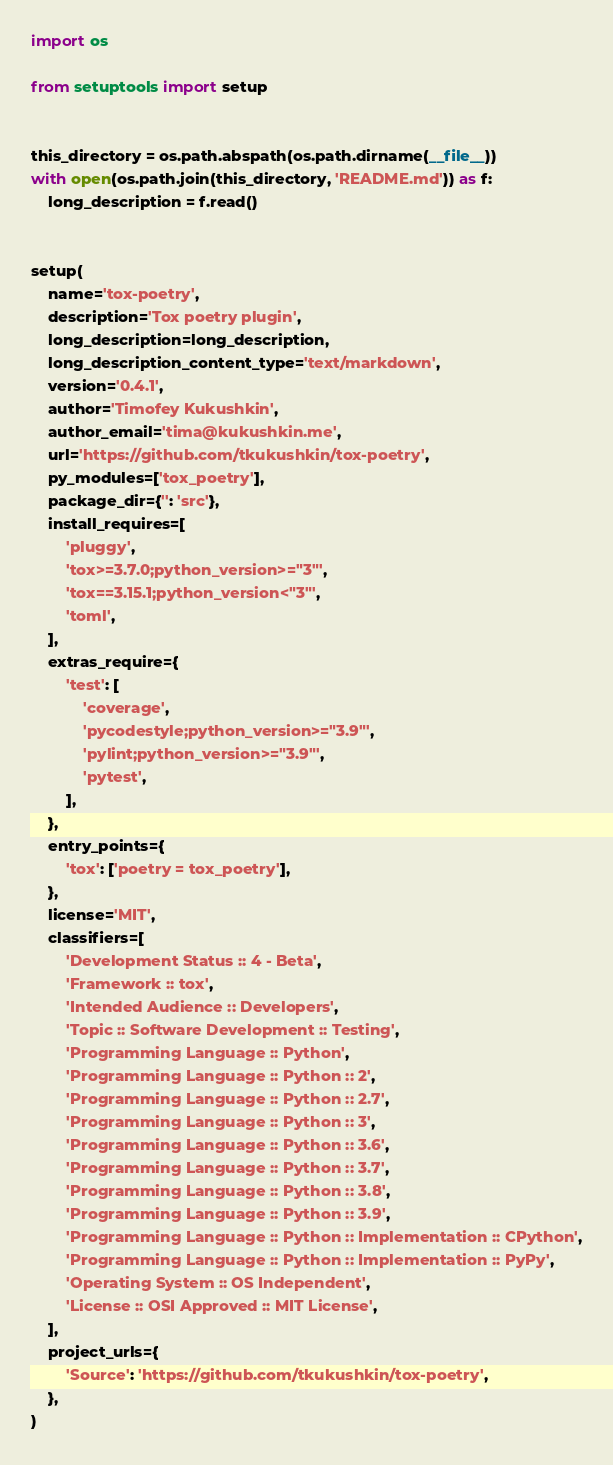<code> <loc_0><loc_0><loc_500><loc_500><_Python_>import os

from setuptools import setup


this_directory = os.path.abspath(os.path.dirname(__file__))
with open(os.path.join(this_directory, 'README.md')) as f:
    long_description = f.read()


setup(
    name='tox-poetry',
    description='Tox poetry plugin',
    long_description=long_description,
    long_description_content_type='text/markdown',
    version='0.4.1',
    author='Timofey Kukushkin',
    author_email='tima@kukushkin.me',
    url='https://github.com/tkukushkin/tox-poetry',
    py_modules=['tox_poetry'],
    package_dir={'': 'src'},
    install_requires=[
        'pluggy',
        'tox>=3.7.0;python_version>="3"',
        'tox==3.15.1;python_version<"3"',
        'toml',
    ],
    extras_require={
        'test': [
            'coverage',
            'pycodestyle;python_version>="3.9"',
            'pylint;python_version>="3.9"',
            'pytest',
        ],
    },
    entry_points={
        'tox': ['poetry = tox_poetry'],
    },
    license='MIT',
    classifiers=[
        'Development Status :: 4 - Beta',
        'Framework :: tox',
        'Intended Audience :: Developers',
        'Topic :: Software Development :: Testing',
        'Programming Language :: Python',
        'Programming Language :: Python :: 2',
        'Programming Language :: Python :: 2.7',
        'Programming Language :: Python :: 3',
        'Programming Language :: Python :: 3.6',
        'Programming Language :: Python :: 3.7',
        'Programming Language :: Python :: 3.8',
        'Programming Language :: Python :: 3.9',
        'Programming Language :: Python :: Implementation :: CPython',
        'Programming Language :: Python :: Implementation :: PyPy',
        'Operating System :: OS Independent',
        'License :: OSI Approved :: MIT License',
    ],
    project_urls={
        'Source': 'https://github.com/tkukushkin/tox-poetry',
    },
)
</code> 